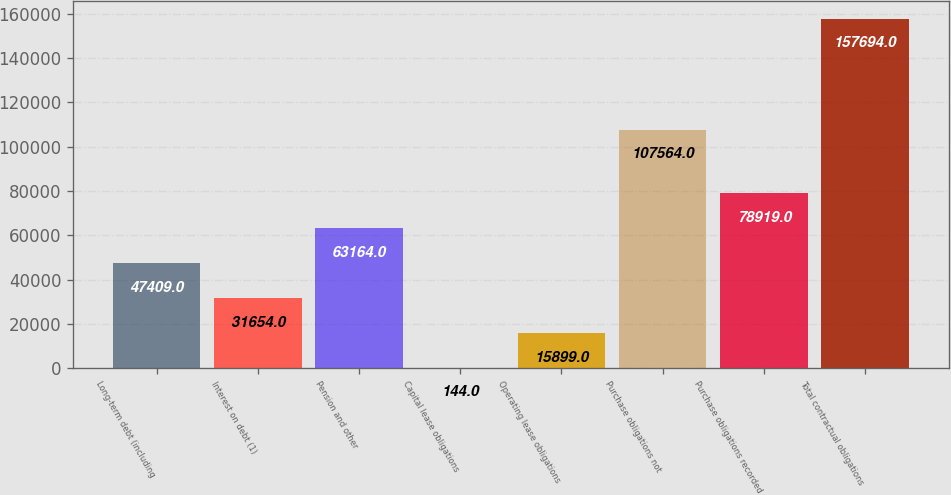<chart> <loc_0><loc_0><loc_500><loc_500><bar_chart><fcel>Long-term debt (including<fcel>Interest on debt (1)<fcel>Pension and other<fcel>Capital lease obligations<fcel>Operating lease obligations<fcel>Purchase obligations not<fcel>Purchase obligations recorded<fcel>Total contractual obligations<nl><fcel>47409<fcel>31654<fcel>63164<fcel>144<fcel>15899<fcel>107564<fcel>78919<fcel>157694<nl></chart> 